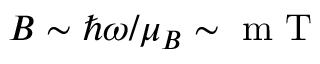Convert formula to latex. <formula><loc_0><loc_0><loc_500><loc_500>B \sim \hbar { \omega } / \mu _ { B } \sim m T</formula> 